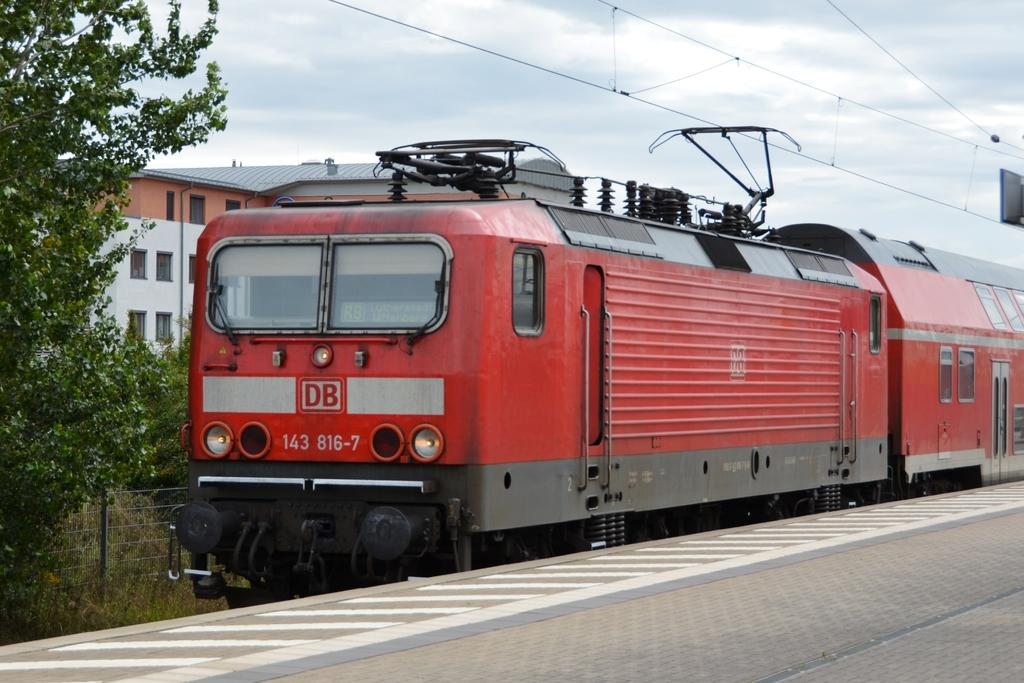<image>
Present a compact description of the photo's key features. a red train on a railroad that is labeled 'db 143 816-7' on the front 